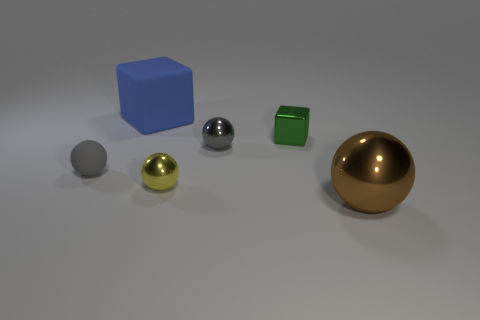The small thing that is both left of the gray metallic sphere and behind the tiny yellow shiny thing has what shape?
Give a very brief answer. Sphere. What number of other small things are the same shape as the tiny green shiny object?
Offer a terse response. 0. There is a brown ball that is the same material as the small green cube; what is its size?
Your answer should be compact. Large. How many spheres are the same size as the blue matte thing?
Give a very brief answer. 1. What size is the thing that is the same color as the small matte ball?
Offer a terse response. Small. What is the color of the shiny ball right of the block in front of the big matte object?
Keep it short and to the point. Brown. Are there any metallic objects that have the same color as the rubber ball?
Offer a terse response. Yes. The matte thing that is the same size as the gray metallic thing is what color?
Keep it short and to the point. Gray. Is the material of the tiny gray sphere that is in front of the gray metallic object the same as the big blue cube?
Provide a short and direct response. Yes. There is a sphere to the left of the rubber object behind the small matte object; are there any brown objects that are behind it?
Your answer should be compact. No. 